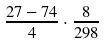Convert formula to latex. <formula><loc_0><loc_0><loc_500><loc_500>\frac { 2 7 - 7 4 } { 4 } \cdot \frac { 8 } { 2 9 8 }</formula> 